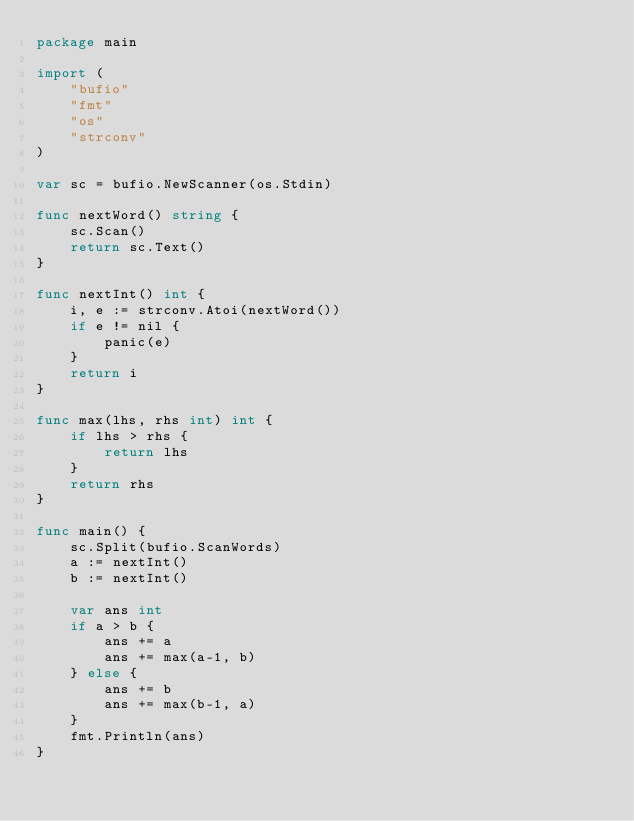<code> <loc_0><loc_0><loc_500><loc_500><_Go_>package main

import (
	"bufio"
	"fmt"
	"os"
	"strconv"
)

var sc = bufio.NewScanner(os.Stdin)

func nextWord() string {
	sc.Scan()
	return sc.Text()
}

func nextInt() int {
	i, e := strconv.Atoi(nextWord())
	if e != nil {
		panic(e)
	}
	return i
}

func max(lhs, rhs int) int {
	if lhs > rhs {
		return lhs
	}
	return rhs
}

func main() {
	sc.Split(bufio.ScanWords)
	a := nextInt()
	b := nextInt()

	var ans int
	if a > b {
		ans += a
		ans += max(a-1, b)
	} else {
		ans += b
		ans += max(b-1, a)
	}
	fmt.Println(ans)
}
</code> 